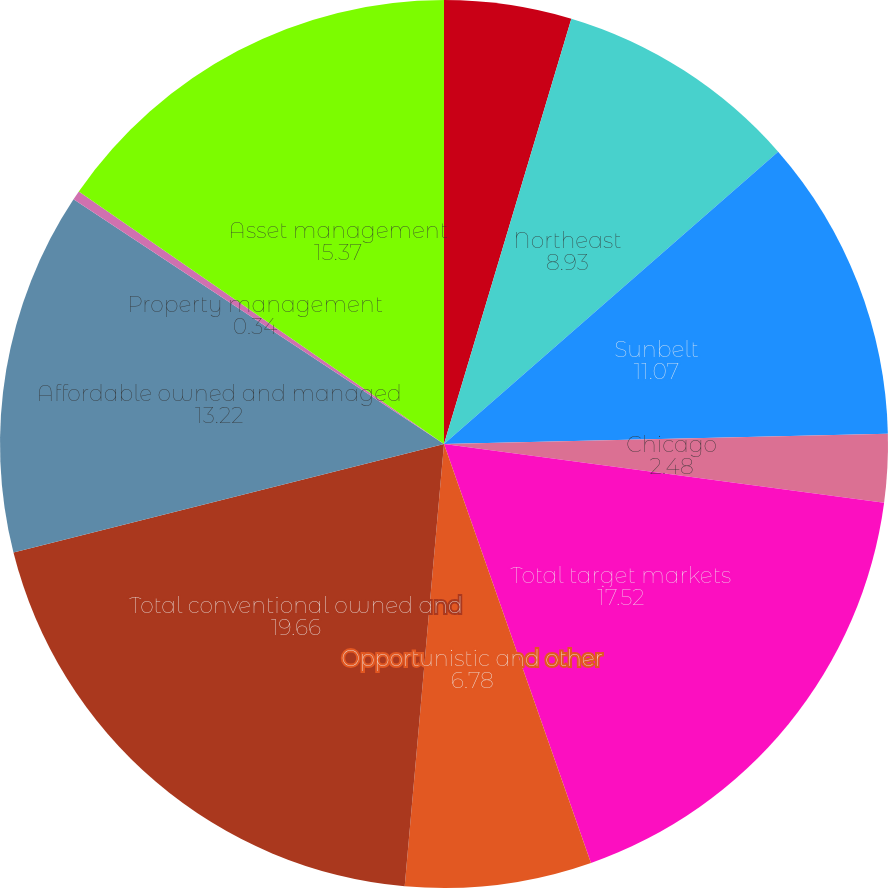<chart> <loc_0><loc_0><loc_500><loc_500><pie_chart><fcel>Pacific<fcel>Northeast<fcel>Sunbelt<fcel>Chicago<fcel>Total target markets<fcel>Opportunistic and other<fcel>Total conventional owned and<fcel>Affordable owned and managed<fcel>Property management<fcel>Asset management<nl><fcel>4.63%<fcel>8.93%<fcel>11.07%<fcel>2.48%<fcel>17.52%<fcel>6.78%<fcel>19.66%<fcel>13.22%<fcel>0.34%<fcel>15.37%<nl></chart> 